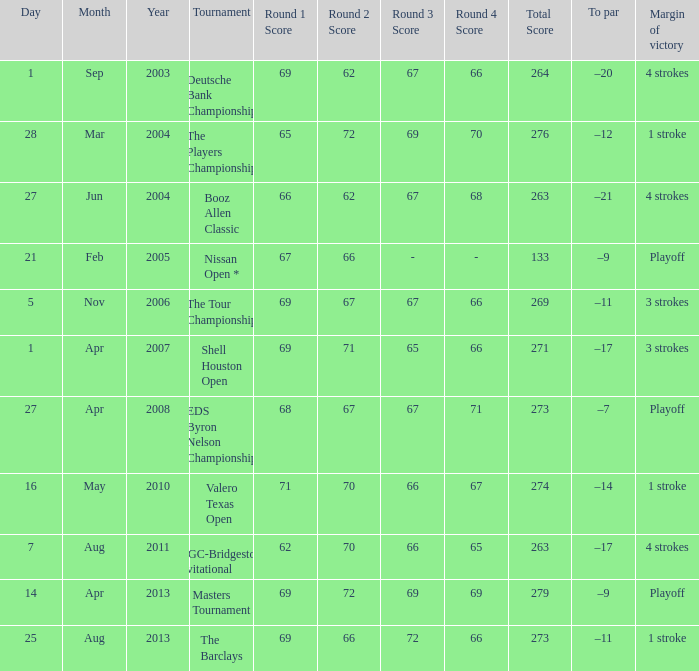Which date has a To par of –12? 28 Mar 2004. 